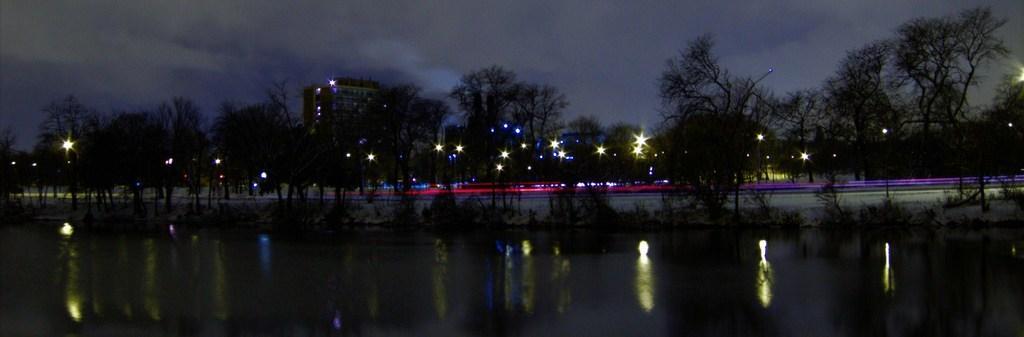Can you describe this image briefly? In this image there is water at the bottom. In the middle there are trees with the lights. At the top there is the sky. In the background there are buildings. This image is taken during the night time. 